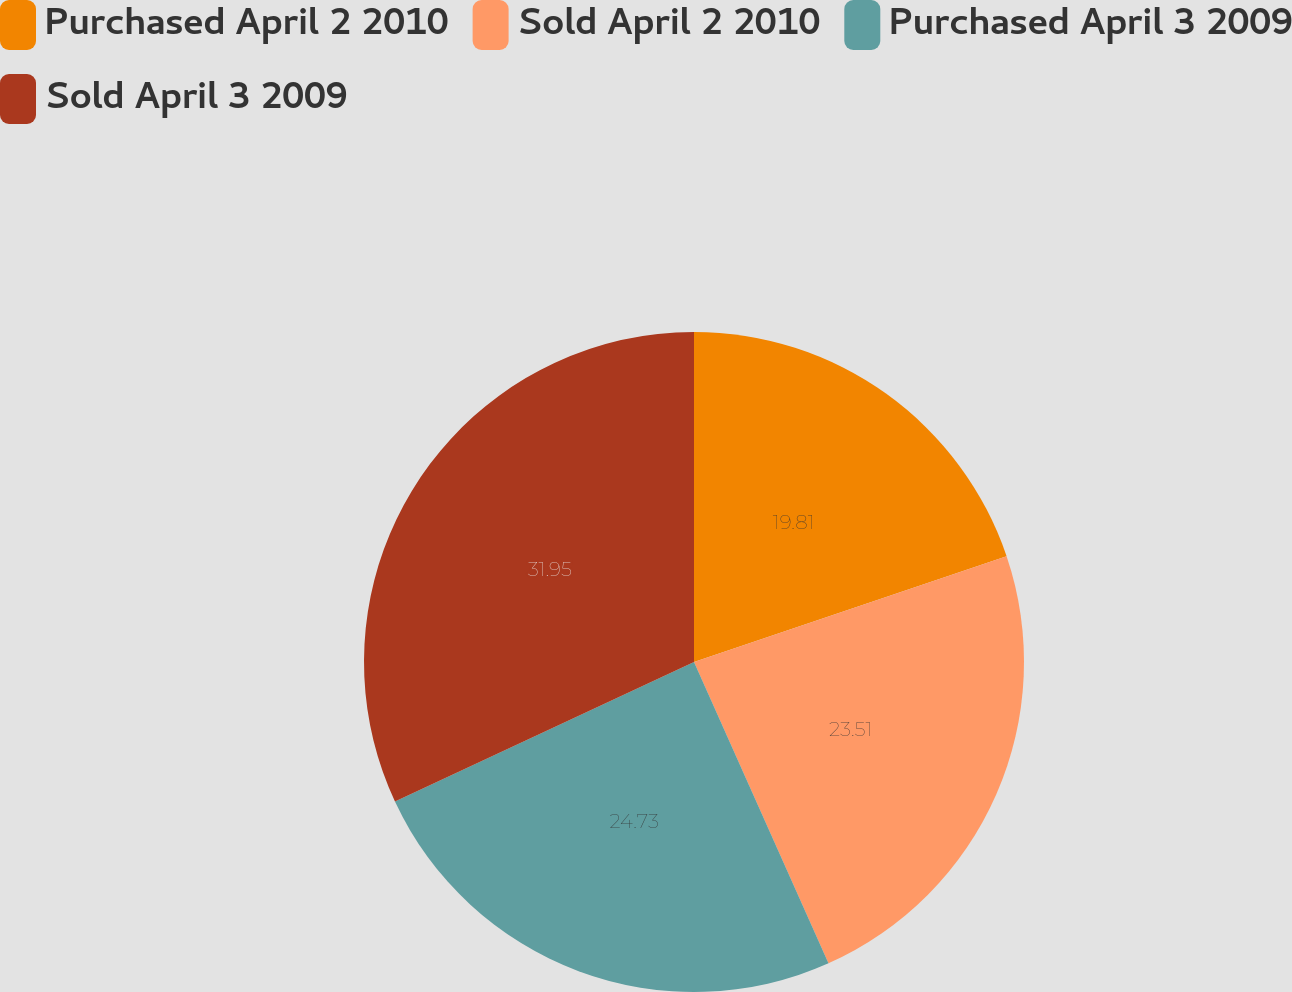Convert chart to OTSL. <chart><loc_0><loc_0><loc_500><loc_500><pie_chart><fcel>Purchased April 2 2010<fcel>Sold April 2 2010<fcel>Purchased April 3 2009<fcel>Sold April 3 2009<nl><fcel>19.81%<fcel>23.51%<fcel>24.73%<fcel>31.95%<nl></chart> 